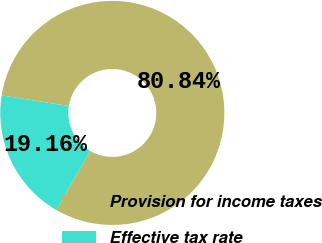Convert chart. <chart><loc_0><loc_0><loc_500><loc_500><pie_chart><fcel>Provision for income taxes<fcel>Effective tax rate<nl><fcel>80.84%<fcel>19.16%<nl></chart> 